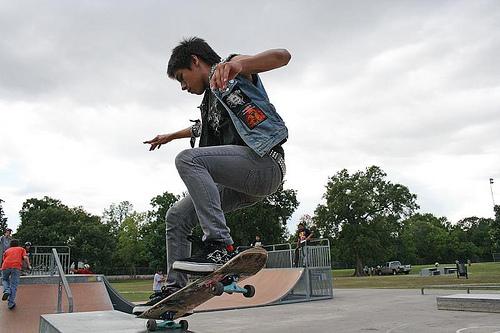Is there a person with orange t shirt?
Quick response, please. Yes. What is the skateboard on?
Write a very short answer. Ramp. Is the athlete wearing wrist guards?
Short answer required. No. What's this kid doing?
Keep it brief. Skateboarding. 